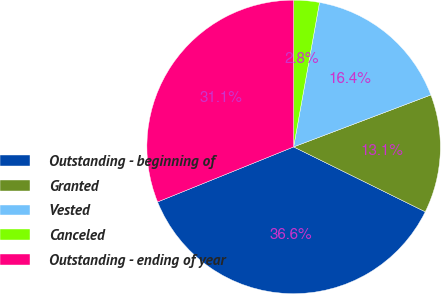Convert chart. <chart><loc_0><loc_0><loc_500><loc_500><pie_chart><fcel>Outstanding - beginning of<fcel>Granted<fcel>Vested<fcel>Canceled<fcel>Outstanding - ending of year<nl><fcel>36.59%<fcel>13.05%<fcel>16.42%<fcel>2.82%<fcel>31.12%<nl></chart> 